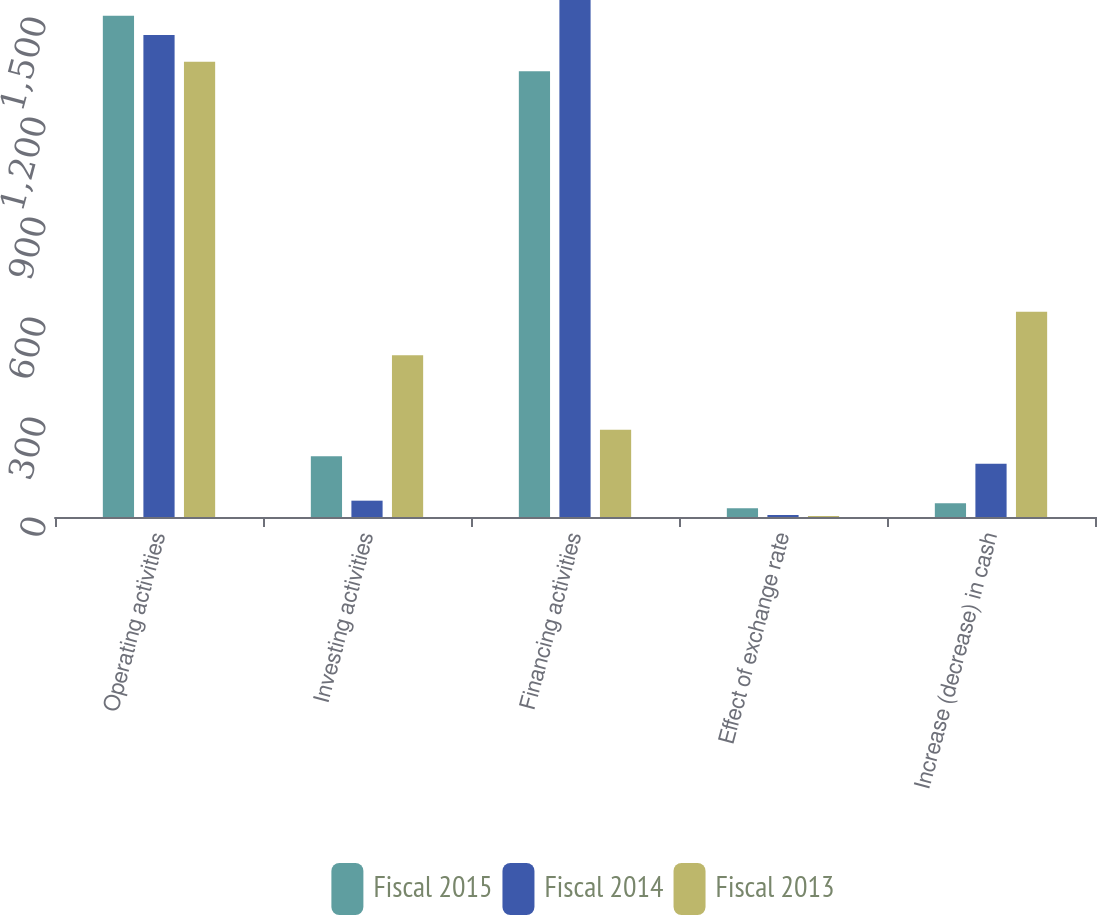<chart> <loc_0><loc_0><loc_500><loc_500><stacked_bar_chart><ecel><fcel>Operating activities<fcel>Investing activities<fcel>Financing activities<fcel>Effect of exchange rate<fcel>Increase (decrease) in cash<nl><fcel>Fiscal 2015<fcel>1504<fcel>182<fcel>1337<fcel>26<fcel>41<nl><fcel>Fiscal 2014<fcel>1446<fcel>49<fcel>1551<fcel>6<fcel>160<nl><fcel>Fiscal 2013<fcel>1366<fcel>485<fcel>262<fcel>3<fcel>616<nl></chart> 